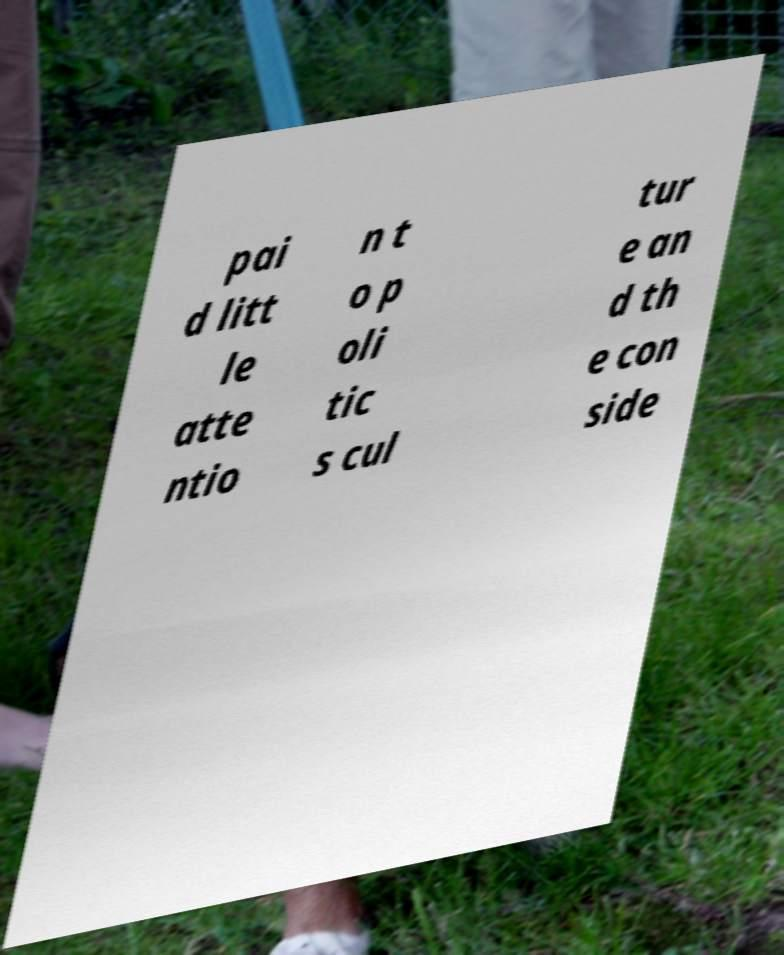Please identify and transcribe the text found in this image. pai d litt le atte ntio n t o p oli tic s cul tur e an d th e con side 